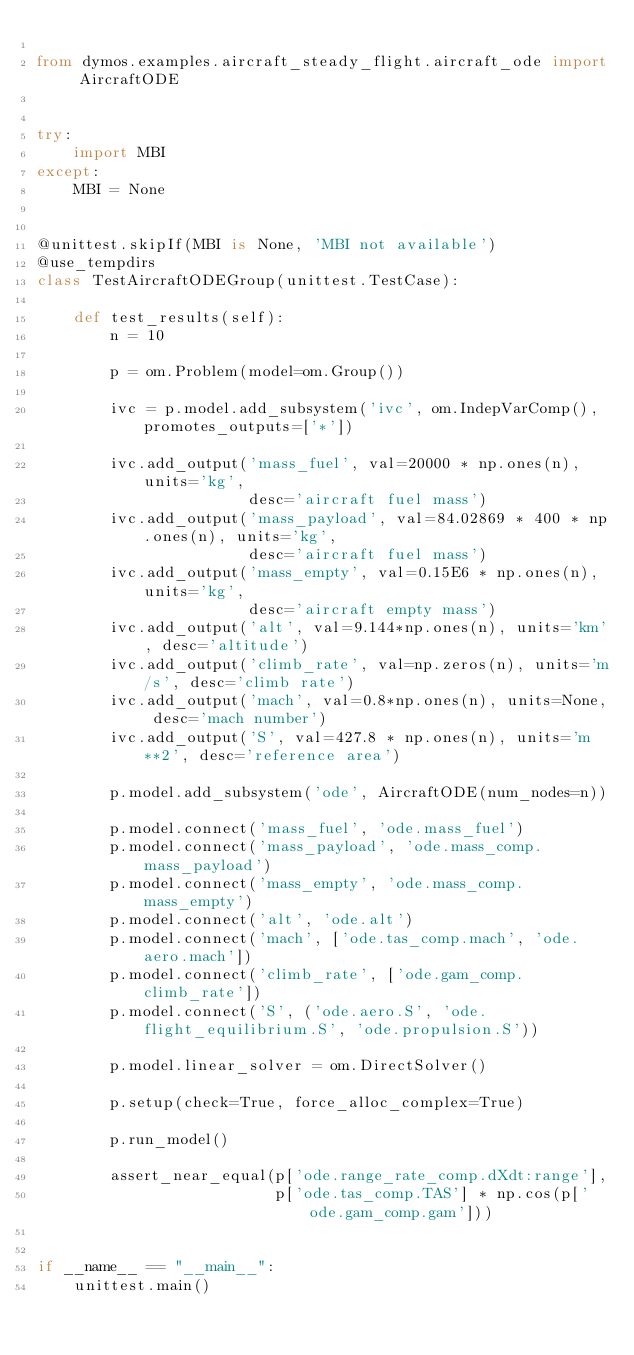Convert code to text. <code><loc_0><loc_0><loc_500><loc_500><_Python_>
from dymos.examples.aircraft_steady_flight.aircraft_ode import AircraftODE


try:
    import MBI
except:
    MBI = None


@unittest.skipIf(MBI is None, 'MBI not available')
@use_tempdirs
class TestAircraftODEGroup(unittest.TestCase):

    def test_results(self):
        n = 10

        p = om.Problem(model=om.Group())

        ivc = p.model.add_subsystem('ivc', om.IndepVarComp(), promotes_outputs=['*'])

        ivc.add_output('mass_fuel', val=20000 * np.ones(n), units='kg',
                       desc='aircraft fuel mass')
        ivc.add_output('mass_payload', val=84.02869 * 400 * np.ones(n), units='kg',
                       desc='aircraft fuel mass')
        ivc.add_output('mass_empty', val=0.15E6 * np.ones(n), units='kg',
                       desc='aircraft empty mass')
        ivc.add_output('alt', val=9.144*np.ones(n), units='km', desc='altitude')
        ivc.add_output('climb_rate', val=np.zeros(n), units='m/s', desc='climb rate')
        ivc.add_output('mach', val=0.8*np.ones(n), units=None, desc='mach number')
        ivc.add_output('S', val=427.8 * np.ones(n), units='m**2', desc='reference area')

        p.model.add_subsystem('ode', AircraftODE(num_nodes=n))

        p.model.connect('mass_fuel', 'ode.mass_fuel')
        p.model.connect('mass_payload', 'ode.mass_comp.mass_payload')
        p.model.connect('mass_empty', 'ode.mass_comp.mass_empty')
        p.model.connect('alt', 'ode.alt')
        p.model.connect('mach', ['ode.tas_comp.mach', 'ode.aero.mach'])
        p.model.connect('climb_rate', ['ode.gam_comp.climb_rate'])
        p.model.connect('S', ('ode.aero.S', 'ode.flight_equilibrium.S', 'ode.propulsion.S'))

        p.model.linear_solver = om.DirectSolver()

        p.setup(check=True, force_alloc_complex=True)

        p.run_model()

        assert_near_equal(p['ode.range_rate_comp.dXdt:range'],
                          p['ode.tas_comp.TAS'] * np.cos(p['ode.gam_comp.gam']))


if __name__ == "__main__":
    unittest.main()
</code> 